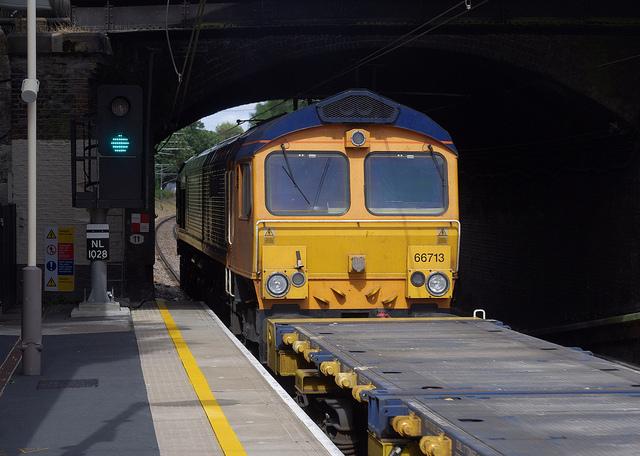Is anyone waiting on the train?
Give a very brief answer. No. Is it daytime?
Answer briefly. Yes. Is the light on the left side green?
Concise answer only. Yes. What color is the train?
Write a very short answer. Yellow. How many trains?
Answer briefly. 1. Is the train entering the tunnel?
Quick response, please. Yes. Is this a freight train?
Short answer required. Yes. 